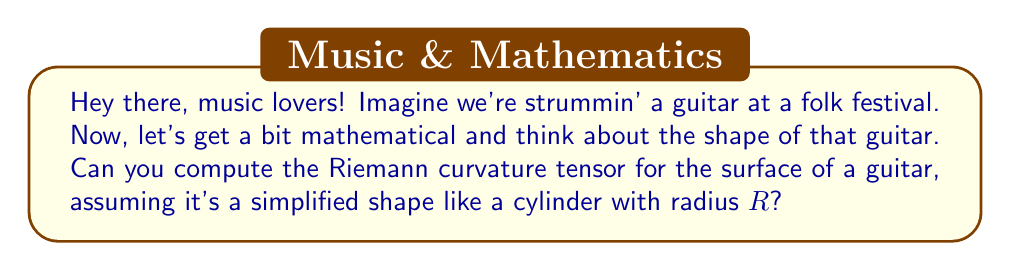Help me with this question. Alright, let's break this down step-by-step, as if we're composing a folk song:

1) First, we need to choose a coordinate system. For a cylinder, we can use cylindrical coordinates $(r, \theta, z)$, where $r = R$ is constant for the surface.

2) The metric tensor for a cylinder in these coordinates is:

   $$g_{ij} = \begin{pmatrix}
   1 & 0 & 0 \\
   0 & R^2 & 0 \\
   0 & 0 & 1
   \end{pmatrix}$$

3) To calculate the Riemann curvature tensor, we need to compute the Christoffel symbols first. The non-zero Christoffel symbols are:

   $$\Gamma^\theta_{r\theta} = \Gamma^\theta_{\theta r} = \frac{1}{R}$$
   $$\Gamma^r_{\theta\theta} = -R$$

4) Now, we can use the formula for the Riemann curvature tensor:

   $$R^i_{jkl} = \partial_k \Gamma^i_{jl} - \partial_l \Gamma^i_{jk} + \Gamma^i_{mk}\Gamma^m_{jl} - \Gamma^i_{ml}\Gamma^m_{jk}$$

5) Calculating the non-zero components:

   $$R^r_{\theta r \theta} = -R^r_{\theta \theta r} = \partial_r \Gamma^r_{\theta\theta} - 0 + 0 - 0 = -1$$
   
   $$R^\theta_{r \theta r} = -R^\theta_{r r \theta} = 0 - \partial_r \Gamma^\theta_{r\theta} + 0 - 0 = 0$$

6) All other components are zero due to the symmetry of the cylinder.

7) Therefore, the only non-zero component of the Riemann curvature tensor is:

   $$R_{r\theta r\theta} = g_{rr}R^r_{\theta r \theta} = -R^2$$

This shows that the curvature is constant and proportional to the square of the radius, just like a simple cylinder.
Answer: $R_{r\theta r\theta} = -R^2$, all other components zero 